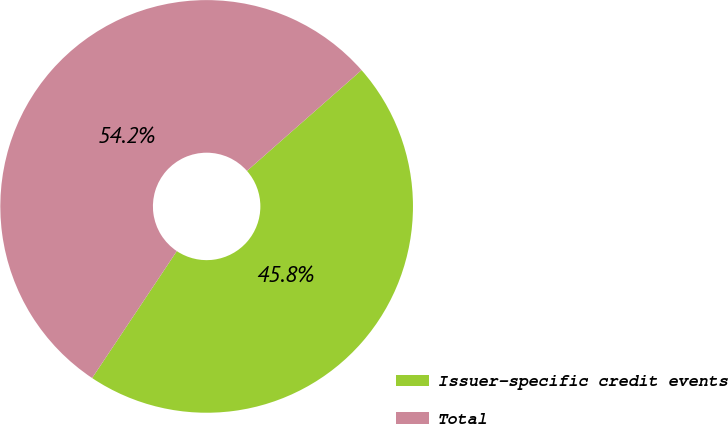Convert chart to OTSL. <chart><loc_0><loc_0><loc_500><loc_500><pie_chart><fcel>Issuer-specific credit events<fcel>Total<nl><fcel>45.85%<fcel>54.15%<nl></chart> 